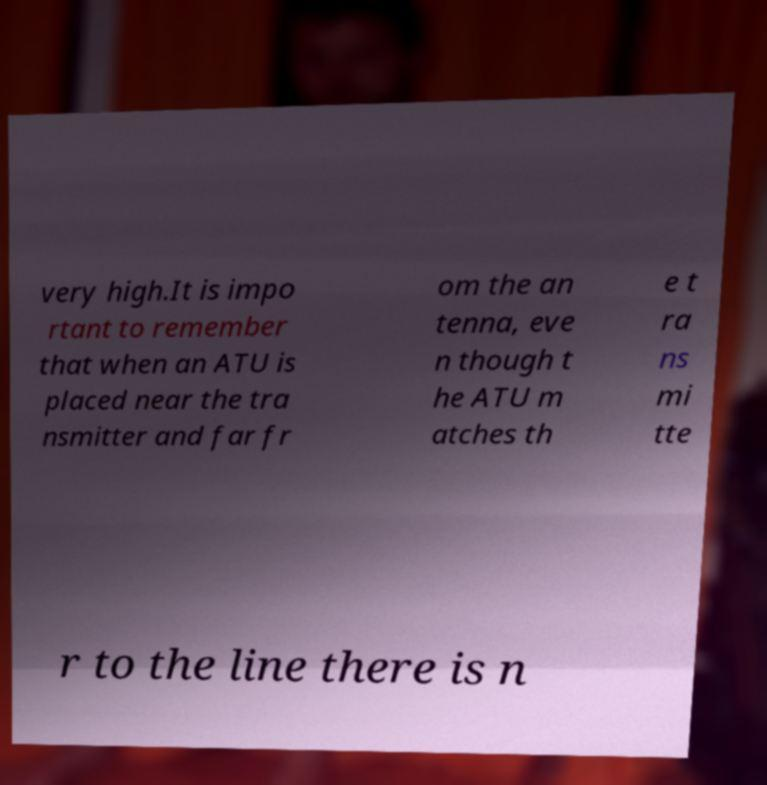Please identify and transcribe the text found in this image. very high.It is impo rtant to remember that when an ATU is placed near the tra nsmitter and far fr om the an tenna, eve n though t he ATU m atches th e t ra ns mi tte r to the line there is n 